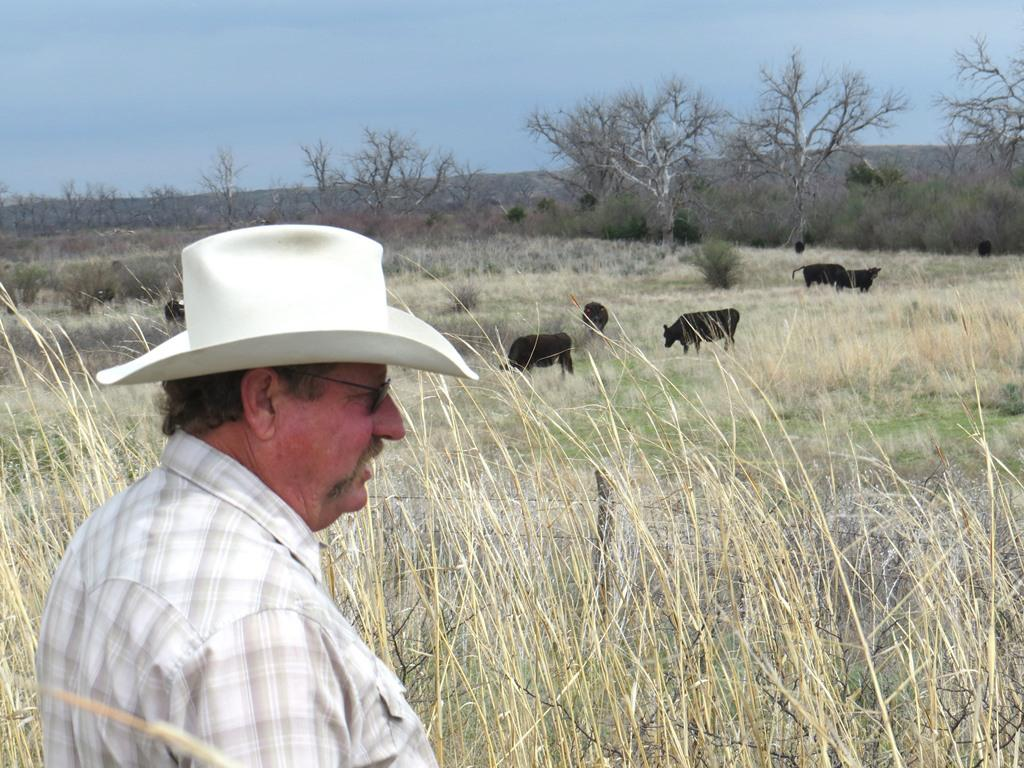What animals can be seen in the image? There are cows in the image. What type of vegetation is on the ground in the image? There is grass on the ground in the image. Can you describe the man in the image? The man is standing in the image, wearing a cap and sunglasses. What else can be seen in the image besides the cows and the man? There are trees in the image, and the sky is blue. What type of lipstick is the man wearing in the image? The man is not wearing lipstick in the image; he is wearing sunglasses and a cap. Is there a tent visible in the image? No, there is no tent present in the image. 